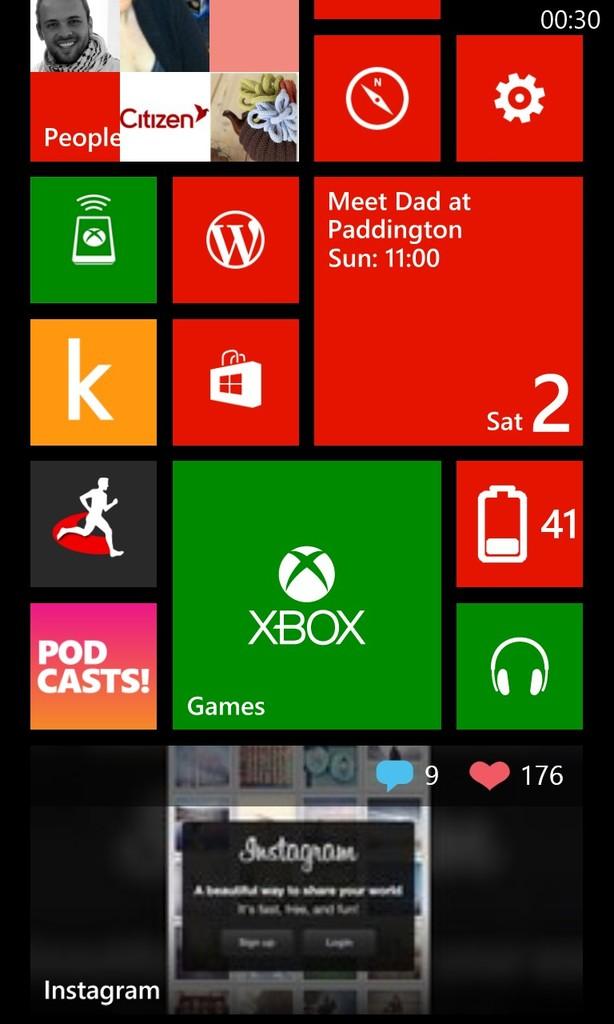What gaming consoles is featured here?
Your answer should be compact. Xbox. 